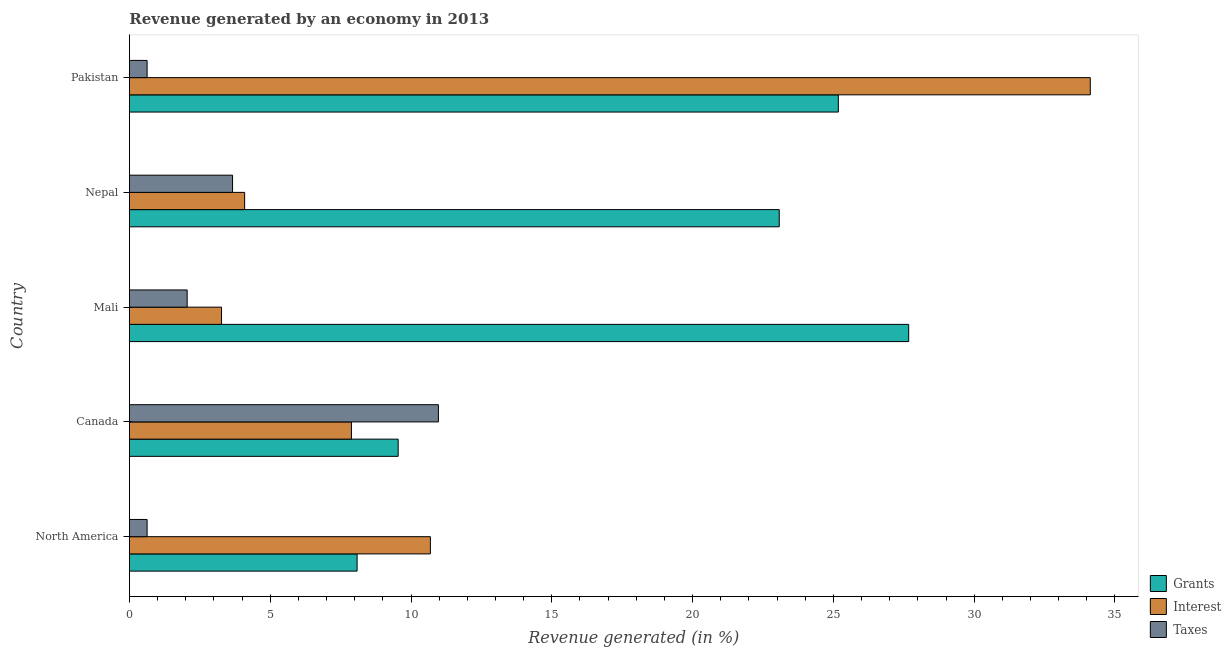How many groups of bars are there?
Your response must be concise. 5. Are the number of bars per tick equal to the number of legend labels?
Give a very brief answer. Yes. Are the number of bars on each tick of the Y-axis equal?
Make the answer very short. Yes. How many bars are there on the 2nd tick from the bottom?
Provide a short and direct response. 3. What is the percentage of revenue generated by grants in North America?
Provide a succinct answer. 8.09. Across all countries, what is the maximum percentage of revenue generated by taxes?
Offer a terse response. 10.97. Across all countries, what is the minimum percentage of revenue generated by interest?
Your answer should be very brief. 3.27. In which country was the percentage of revenue generated by grants minimum?
Ensure brevity in your answer.  North America. What is the total percentage of revenue generated by taxes in the graph?
Ensure brevity in your answer.  17.95. What is the difference between the percentage of revenue generated by grants in Canada and that in Mali?
Make the answer very short. -18.13. What is the difference between the percentage of revenue generated by grants in Pakistan and the percentage of revenue generated by taxes in Nepal?
Your answer should be very brief. 21.51. What is the average percentage of revenue generated by interest per country?
Your response must be concise. 12.01. What is the difference between the percentage of revenue generated by interest and percentage of revenue generated by grants in Pakistan?
Your response must be concise. 8.95. In how many countries, is the percentage of revenue generated by taxes greater than 15 %?
Your answer should be very brief. 0. What is the ratio of the percentage of revenue generated by interest in Mali to that in North America?
Offer a terse response. 0.31. Is the percentage of revenue generated by taxes in Canada less than that in North America?
Give a very brief answer. No. Is the difference between the percentage of revenue generated by interest in North America and Pakistan greater than the difference between the percentage of revenue generated by taxes in North America and Pakistan?
Your answer should be compact. No. What is the difference between the highest and the second highest percentage of revenue generated by taxes?
Offer a very short reply. 7.31. What is the difference between the highest and the lowest percentage of revenue generated by interest?
Make the answer very short. 30.85. What does the 2nd bar from the top in Nepal represents?
Provide a succinct answer. Interest. What does the 2nd bar from the bottom in Pakistan represents?
Offer a very short reply. Interest. Is it the case that in every country, the sum of the percentage of revenue generated by grants and percentage of revenue generated by interest is greater than the percentage of revenue generated by taxes?
Your answer should be compact. Yes. Are all the bars in the graph horizontal?
Offer a terse response. Yes. How many countries are there in the graph?
Keep it short and to the point. 5. Does the graph contain grids?
Keep it short and to the point. No. What is the title of the graph?
Make the answer very short. Revenue generated by an economy in 2013. What is the label or title of the X-axis?
Provide a succinct answer. Revenue generated (in %). What is the label or title of the Y-axis?
Offer a terse response. Country. What is the Revenue generated (in %) in Grants in North America?
Offer a very short reply. 8.09. What is the Revenue generated (in %) of Interest in North America?
Offer a very short reply. 10.69. What is the Revenue generated (in %) in Taxes in North America?
Provide a short and direct response. 0.63. What is the Revenue generated (in %) of Grants in Canada?
Provide a succinct answer. 9.54. What is the Revenue generated (in %) of Interest in Canada?
Your answer should be very brief. 7.88. What is the Revenue generated (in %) of Taxes in Canada?
Offer a terse response. 10.97. What is the Revenue generated (in %) of Grants in Mali?
Provide a succinct answer. 27.67. What is the Revenue generated (in %) in Interest in Mali?
Your response must be concise. 3.27. What is the Revenue generated (in %) in Taxes in Mali?
Your answer should be compact. 2.05. What is the Revenue generated (in %) in Grants in Nepal?
Your answer should be very brief. 23.08. What is the Revenue generated (in %) of Interest in Nepal?
Keep it short and to the point. 4.09. What is the Revenue generated (in %) in Taxes in Nepal?
Make the answer very short. 3.66. What is the Revenue generated (in %) of Grants in Pakistan?
Provide a succinct answer. 25.18. What is the Revenue generated (in %) of Interest in Pakistan?
Your answer should be very brief. 34.12. What is the Revenue generated (in %) of Taxes in Pakistan?
Your answer should be very brief. 0.63. Across all countries, what is the maximum Revenue generated (in %) of Grants?
Provide a short and direct response. 27.67. Across all countries, what is the maximum Revenue generated (in %) of Interest?
Give a very brief answer. 34.12. Across all countries, what is the maximum Revenue generated (in %) in Taxes?
Keep it short and to the point. 10.97. Across all countries, what is the minimum Revenue generated (in %) of Grants?
Your answer should be compact. 8.09. Across all countries, what is the minimum Revenue generated (in %) of Interest?
Offer a terse response. 3.27. Across all countries, what is the minimum Revenue generated (in %) in Taxes?
Ensure brevity in your answer.  0.63. What is the total Revenue generated (in %) in Grants in the graph?
Offer a very short reply. 93.56. What is the total Revenue generated (in %) of Interest in the graph?
Your answer should be compact. 60.06. What is the total Revenue generated (in %) in Taxes in the graph?
Your answer should be compact. 17.95. What is the difference between the Revenue generated (in %) of Grants in North America and that in Canada?
Offer a very short reply. -1.46. What is the difference between the Revenue generated (in %) in Interest in North America and that in Canada?
Offer a terse response. 2.8. What is the difference between the Revenue generated (in %) of Taxes in North America and that in Canada?
Your answer should be compact. -10.34. What is the difference between the Revenue generated (in %) in Grants in North America and that in Mali?
Keep it short and to the point. -19.59. What is the difference between the Revenue generated (in %) in Interest in North America and that in Mali?
Offer a very short reply. 7.42. What is the difference between the Revenue generated (in %) in Taxes in North America and that in Mali?
Offer a terse response. -1.42. What is the difference between the Revenue generated (in %) in Grants in North America and that in Nepal?
Make the answer very short. -14.99. What is the difference between the Revenue generated (in %) of Interest in North America and that in Nepal?
Keep it short and to the point. 6.6. What is the difference between the Revenue generated (in %) of Taxes in North America and that in Nepal?
Provide a succinct answer. -3.03. What is the difference between the Revenue generated (in %) in Grants in North America and that in Pakistan?
Make the answer very short. -17.09. What is the difference between the Revenue generated (in %) of Interest in North America and that in Pakistan?
Make the answer very short. -23.43. What is the difference between the Revenue generated (in %) of Taxes in North America and that in Pakistan?
Provide a succinct answer. 0. What is the difference between the Revenue generated (in %) of Grants in Canada and that in Mali?
Your response must be concise. -18.13. What is the difference between the Revenue generated (in %) in Interest in Canada and that in Mali?
Offer a terse response. 4.61. What is the difference between the Revenue generated (in %) in Taxes in Canada and that in Mali?
Your response must be concise. 8.92. What is the difference between the Revenue generated (in %) of Grants in Canada and that in Nepal?
Offer a terse response. -13.53. What is the difference between the Revenue generated (in %) of Interest in Canada and that in Nepal?
Offer a very short reply. 3.79. What is the difference between the Revenue generated (in %) of Taxes in Canada and that in Nepal?
Your answer should be compact. 7.31. What is the difference between the Revenue generated (in %) of Grants in Canada and that in Pakistan?
Give a very brief answer. -15.63. What is the difference between the Revenue generated (in %) of Interest in Canada and that in Pakistan?
Provide a succinct answer. -26.24. What is the difference between the Revenue generated (in %) in Taxes in Canada and that in Pakistan?
Offer a terse response. 10.34. What is the difference between the Revenue generated (in %) of Grants in Mali and that in Nepal?
Your response must be concise. 4.6. What is the difference between the Revenue generated (in %) of Interest in Mali and that in Nepal?
Provide a succinct answer. -0.82. What is the difference between the Revenue generated (in %) of Taxes in Mali and that in Nepal?
Offer a terse response. -1.61. What is the difference between the Revenue generated (in %) in Grants in Mali and that in Pakistan?
Make the answer very short. 2.5. What is the difference between the Revenue generated (in %) of Interest in Mali and that in Pakistan?
Offer a terse response. -30.85. What is the difference between the Revenue generated (in %) in Taxes in Mali and that in Pakistan?
Keep it short and to the point. 1.42. What is the difference between the Revenue generated (in %) in Grants in Nepal and that in Pakistan?
Your answer should be very brief. -2.1. What is the difference between the Revenue generated (in %) in Interest in Nepal and that in Pakistan?
Provide a succinct answer. -30.03. What is the difference between the Revenue generated (in %) of Taxes in Nepal and that in Pakistan?
Your response must be concise. 3.03. What is the difference between the Revenue generated (in %) in Grants in North America and the Revenue generated (in %) in Interest in Canada?
Your answer should be compact. 0.2. What is the difference between the Revenue generated (in %) in Grants in North America and the Revenue generated (in %) in Taxes in Canada?
Offer a very short reply. -2.89. What is the difference between the Revenue generated (in %) in Interest in North America and the Revenue generated (in %) in Taxes in Canada?
Your answer should be very brief. -0.28. What is the difference between the Revenue generated (in %) in Grants in North America and the Revenue generated (in %) in Interest in Mali?
Provide a succinct answer. 4.81. What is the difference between the Revenue generated (in %) in Grants in North America and the Revenue generated (in %) in Taxes in Mali?
Your answer should be compact. 6.03. What is the difference between the Revenue generated (in %) of Interest in North America and the Revenue generated (in %) of Taxes in Mali?
Provide a succinct answer. 8.64. What is the difference between the Revenue generated (in %) of Grants in North America and the Revenue generated (in %) of Interest in Nepal?
Provide a succinct answer. 3.99. What is the difference between the Revenue generated (in %) in Grants in North America and the Revenue generated (in %) in Taxes in Nepal?
Provide a short and direct response. 4.42. What is the difference between the Revenue generated (in %) of Interest in North America and the Revenue generated (in %) of Taxes in Nepal?
Give a very brief answer. 7.03. What is the difference between the Revenue generated (in %) of Grants in North America and the Revenue generated (in %) of Interest in Pakistan?
Provide a short and direct response. -26.04. What is the difference between the Revenue generated (in %) in Grants in North America and the Revenue generated (in %) in Taxes in Pakistan?
Ensure brevity in your answer.  7.46. What is the difference between the Revenue generated (in %) in Interest in North America and the Revenue generated (in %) in Taxes in Pakistan?
Your answer should be very brief. 10.06. What is the difference between the Revenue generated (in %) in Grants in Canada and the Revenue generated (in %) in Interest in Mali?
Provide a short and direct response. 6.27. What is the difference between the Revenue generated (in %) of Grants in Canada and the Revenue generated (in %) of Taxes in Mali?
Offer a very short reply. 7.49. What is the difference between the Revenue generated (in %) in Interest in Canada and the Revenue generated (in %) in Taxes in Mali?
Your response must be concise. 5.83. What is the difference between the Revenue generated (in %) in Grants in Canada and the Revenue generated (in %) in Interest in Nepal?
Your answer should be very brief. 5.45. What is the difference between the Revenue generated (in %) of Grants in Canada and the Revenue generated (in %) of Taxes in Nepal?
Offer a very short reply. 5.88. What is the difference between the Revenue generated (in %) of Interest in Canada and the Revenue generated (in %) of Taxes in Nepal?
Offer a very short reply. 4.22. What is the difference between the Revenue generated (in %) in Grants in Canada and the Revenue generated (in %) in Interest in Pakistan?
Your response must be concise. -24.58. What is the difference between the Revenue generated (in %) of Grants in Canada and the Revenue generated (in %) of Taxes in Pakistan?
Your answer should be compact. 8.92. What is the difference between the Revenue generated (in %) of Interest in Canada and the Revenue generated (in %) of Taxes in Pakistan?
Your response must be concise. 7.26. What is the difference between the Revenue generated (in %) in Grants in Mali and the Revenue generated (in %) in Interest in Nepal?
Offer a terse response. 23.58. What is the difference between the Revenue generated (in %) in Grants in Mali and the Revenue generated (in %) in Taxes in Nepal?
Your answer should be very brief. 24.01. What is the difference between the Revenue generated (in %) of Interest in Mali and the Revenue generated (in %) of Taxes in Nepal?
Offer a very short reply. -0.39. What is the difference between the Revenue generated (in %) in Grants in Mali and the Revenue generated (in %) in Interest in Pakistan?
Offer a terse response. -6.45. What is the difference between the Revenue generated (in %) of Grants in Mali and the Revenue generated (in %) of Taxes in Pakistan?
Ensure brevity in your answer.  27.05. What is the difference between the Revenue generated (in %) in Interest in Mali and the Revenue generated (in %) in Taxes in Pakistan?
Provide a short and direct response. 2.64. What is the difference between the Revenue generated (in %) of Grants in Nepal and the Revenue generated (in %) of Interest in Pakistan?
Your response must be concise. -11.05. What is the difference between the Revenue generated (in %) of Grants in Nepal and the Revenue generated (in %) of Taxes in Pakistan?
Provide a short and direct response. 22.45. What is the difference between the Revenue generated (in %) in Interest in Nepal and the Revenue generated (in %) in Taxes in Pakistan?
Ensure brevity in your answer.  3.46. What is the average Revenue generated (in %) of Grants per country?
Provide a short and direct response. 18.71. What is the average Revenue generated (in %) of Interest per country?
Offer a terse response. 12.01. What is the average Revenue generated (in %) in Taxes per country?
Your answer should be compact. 3.59. What is the difference between the Revenue generated (in %) in Grants and Revenue generated (in %) in Interest in North America?
Your answer should be compact. -2.6. What is the difference between the Revenue generated (in %) of Grants and Revenue generated (in %) of Taxes in North America?
Keep it short and to the point. 7.46. What is the difference between the Revenue generated (in %) of Interest and Revenue generated (in %) of Taxes in North America?
Provide a short and direct response. 10.06. What is the difference between the Revenue generated (in %) in Grants and Revenue generated (in %) in Interest in Canada?
Give a very brief answer. 1.66. What is the difference between the Revenue generated (in %) in Grants and Revenue generated (in %) in Taxes in Canada?
Keep it short and to the point. -1.43. What is the difference between the Revenue generated (in %) of Interest and Revenue generated (in %) of Taxes in Canada?
Your response must be concise. -3.09. What is the difference between the Revenue generated (in %) in Grants and Revenue generated (in %) in Interest in Mali?
Ensure brevity in your answer.  24.4. What is the difference between the Revenue generated (in %) in Grants and Revenue generated (in %) in Taxes in Mali?
Provide a short and direct response. 25.62. What is the difference between the Revenue generated (in %) of Interest and Revenue generated (in %) of Taxes in Mali?
Provide a short and direct response. 1.22. What is the difference between the Revenue generated (in %) of Grants and Revenue generated (in %) of Interest in Nepal?
Provide a short and direct response. 18.99. What is the difference between the Revenue generated (in %) in Grants and Revenue generated (in %) in Taxes in Nepal?
Your response must be concise. 19.41. What is the difference between the Revenue generated (in %) of Interest and Revenue generated (in %) of Taxes in Nepal?
Provide a short and direct response. 0.43. What is the difference between the Revenue generated (in %) in Grants and Revenue generated (in %) in Interest in Pakistan?
Provide a succinct answer. -8.95. What is the difference between the Revenue generated (in %) of Grants and Revenue generated (in %) of Taxes in Pakistan?
Provide a succinct answer. 24.55. What is the difference between the Revenue generated (in %) of Interest and Revenue generated (in %) of Taxes in Pakistan?
Provide a short and direct response. 33.49. What is the ratio of the Revenue generated (in %) in Grants in North America to that in Canada?
Your answer should be very brief. 0.85. What is the ratio of the Revenue generated (in %) in Interest in North America to that in Canada?
Provide a succinct answer. 1.36. What is the ratio of the Revenue generated (in %) of Taxes in North America to that in Canada?
Make the answer very short. 0.06. What is the ratio of the Revenue generated (in %) of Grants in North America to that in Mali?
Make the answer very short. 0.29. What is the ratio of the Revenue generated (in %) in Interest in North America to that in Mali?
Provide a succinct answer. 3.27. What is the ratio of the Revenue generated (in %) in Taxes in North America to that in Mali?
Provide a succinct answer. 0.31. What is the ratio of the Revenue generated (in %) of Grants in North America to that in Nepal?
Offer a very short reply. 0.35. What is the ratio of the Revenue generated (in %) of Interest in North America to that in Nepal?
Offer a very short reply. 2.61. What is the ratio of the Revenue generated (in %) of Taxes in North America to that in Nepal?
Make the answer very short. 0.17. What is the ratio of the Revenue generated (in %) in Grants in North America to that in Pakistan?
Ensure brevity in your answer.  0.32. What is the ratio of the Revenue generated (in %) of Interest in North America to that in Pakistan?
Make the answer very short. 0.31. What is the ratio of the Revenue generated (in %) of Taxes in North America to that in Pakistan?
Your answer should be compact. 1. What is the ratio of the Revenue generated (in %) of Grants in Canada to that in Mali?
Provide a succinct answer. 0.34. What is the ratio of the Revenue generated (in %) in Interest in Canada to that in Mali?
Your response must be concise. 2.41. What is the ratio of the Revenue generated (in %) of Taxes in Canada to that in Mali?
Ensure brevity in your answer.  5.35. What is the ratio of the Revenue generated (in %) of Grants in Canada to that in Nepal?
Keep it short and to the point. 0.41. What is the ratio of the Revenue generated (in %) of Interest in Canada to that in Nepal?
Keep it short and to the point. 1.93. What is the ratio of the Revenue generated (in %) of Taxes in Canada to that in Nepal?
Make the answer very short. 3. What is the ratio of the Revenue generated (in %) in Grants in Canada to that in Pakistan?
Your response must be concise. 0.38. What is the ratio of the Revenue generated (in %) of Interest in Canada to that in Pakistan?
Provide a short and direct response. 0.23. What is the ratio of the Revenue generated (in %) in Taxes in Canada to that in Pakistan?
Offer a very short reply. 17.45. What is the ratio of the Revenue generated (in %) in Grants in Mali to that in Nepal?
Provide a short and direct response. 1.2. What is the ratio of the Revenue generated (in %) in Interest in Mali to that in Nepal?
Your answer should be very brief. 0.8. What is the ratio of the Revenue generated (in %) in Taxes in Mali to that in Nepal?
Provide a succinct answer. 0.56. What is the ratio of the Revenue generated (in %) of Grants in Mali to that in Pakistan?
Provide a succinct answer. 1.1. What is the ratio of the Revenue generated (in %) in Interest in Mali to that in Pakistan?
Keep it short and to the point. 0.1. What is the ratio of the Revenue generated (in %) of Taxes in Mali to that in Pakistan?
Your response must be concise. 3.26. What is the ratio of the Revenue generated (in %) of Grants in Nepal to that in Pakistan?
Give a very brief answer. 0.92. What is the ratio of the Revenue generated (in %) in Interest in Nepal to that in Pakistan?
Offer a very short reply. 0.12. What is the ratio of the Revenue generated (in %) of Taxes in Nepal to that in Pakistan?
Provide a short and direct response. 5.83. What is the difference between the highest and the second highest Revenue generated (in %) in Grants?
Ensure brevity in your answer.  2.5. What is the difference between the highest and the second highest Revenue generated (in %) of Interest?
Make the answer very short. 23.43. What is the difference between the highest and the second highest Revenue generated (in %) of Taxes?
Your answer should be very brief. 7.31. What is the difference between the highest and the lowest Revenue generated (in %) of Grants?
Give a very brief answer. 19.59. What is the difference between the highest and the lowest Revenue generated (in %) of Interest?
Provide a short and direct response. 30.85. What is the difference between the highest and the lowest Revenue generated (in %) of Taxes?
Keep it short and to the point. 10.34. 